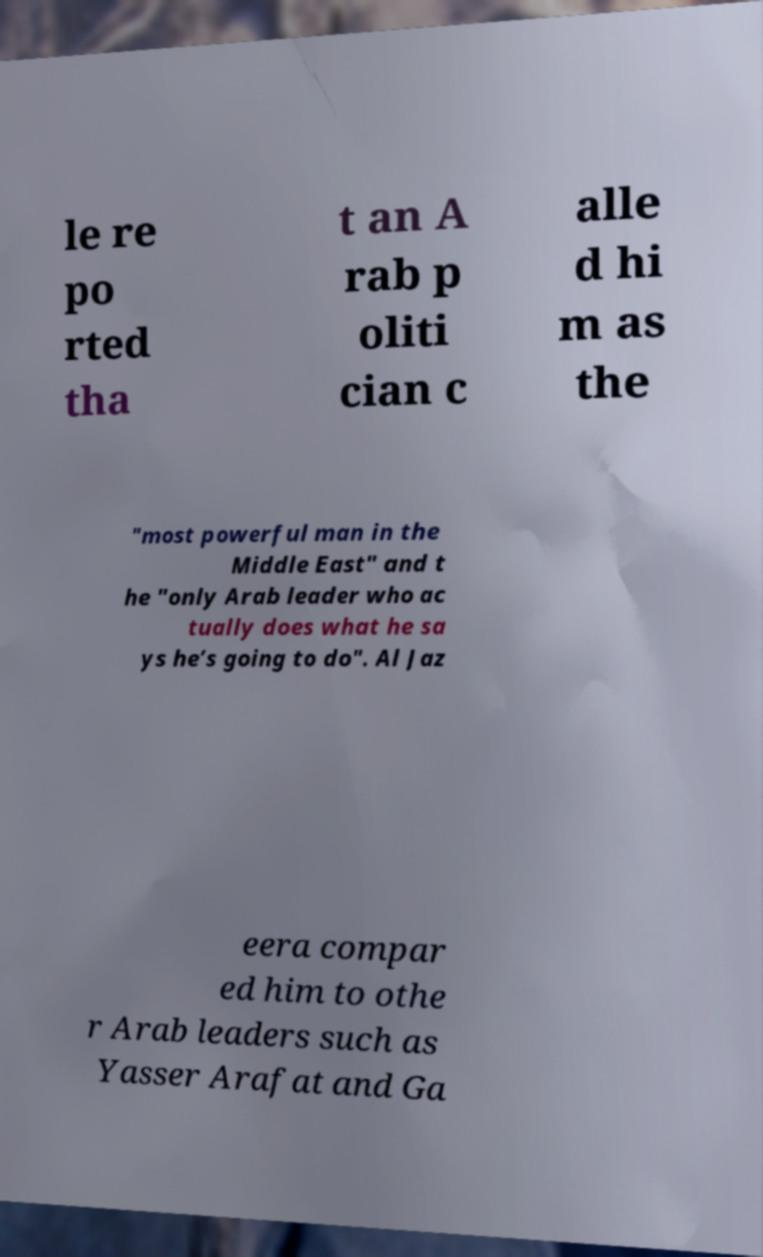What messages or text are displayed in this image? I need them in a readable, typed format. le re po rted tha t an A rab p oliti cian c alle d hi m as the "most powerful man in the Middle East" and t he "only Arab leader who ac tually does what he sa ys he’s going to do". Al Jaz eera compar ed him to othe r Arab leaders such as Yasser Arafat and Ga 